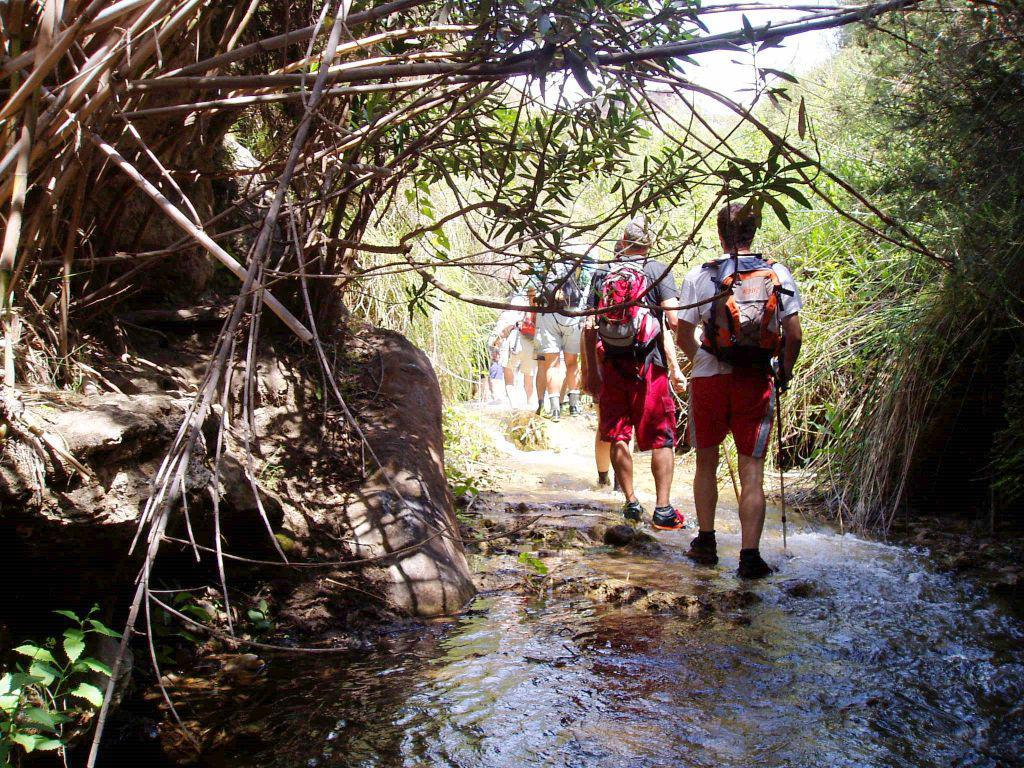How many people are in the image? There is a group of people in the image. What is located at the bottom of the image? There is water visible at the bottom of the image. What is in front of the people in the image? There are trees in front of the people. What can be seen above the people in the image? The sky is visible in the image. What key is the girl holding in the image? There is no girl or key present in the image. 